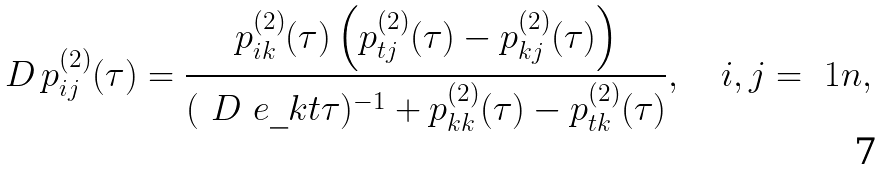Convert formula to latex. <formula><loc_0><loc_0><loc_500><loc_500>\ D \, p ^ { ( 2 ) } _ { i j } ( \tau ) = \frac { p ^ { ( 2 ) } _ { i k } ( \tau ) \left ( p ^ { ( 2 ) } _ { t j } ( \tau ) - p ^ { ( 2 ) } _ { k j } ( \tau ) \right ) } { ( \ D \ e \_ { k t } \tau ) ^ { - 1 } + p ^ { ( 2 ) } _ { k k } ( \tau ) - p ^ { ( 2 ) } _ { t k } ( \tau ) } , \quad i , j = \ 1 n ,</formula> 